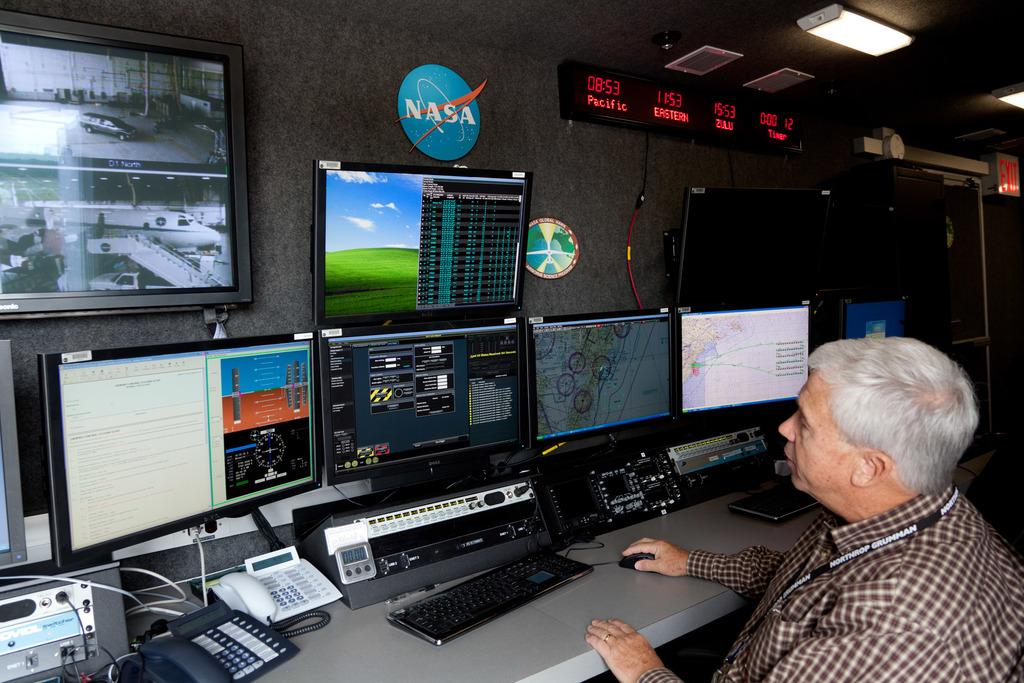<image>
Present a compact description of the photo's key features. The NASA logo hangs on a wall over an employee sitting at his workstation. 